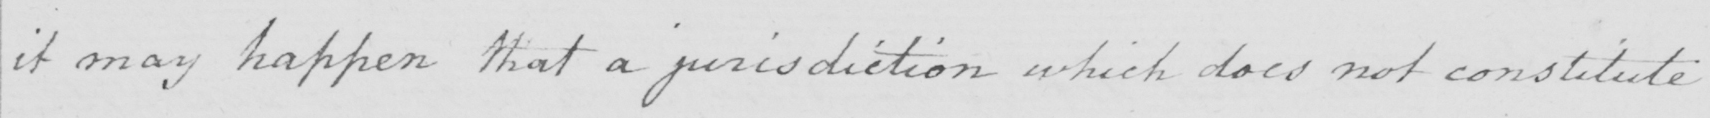Please transcribe the handwritten text in this image. it may happen that a jurisdiction which does not constitute 